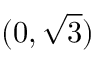<formula> <loc_0><loc_0><loc_500><loc_500>( 0 , { \sqrt { 3 } } )</formula> 